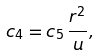<formula> <loc_0><loc_0><loc_500><loc_500>c _ { 4 } = c _ { 5 } \, \frac { r ^ { 2 } } { u } ,</formula> 